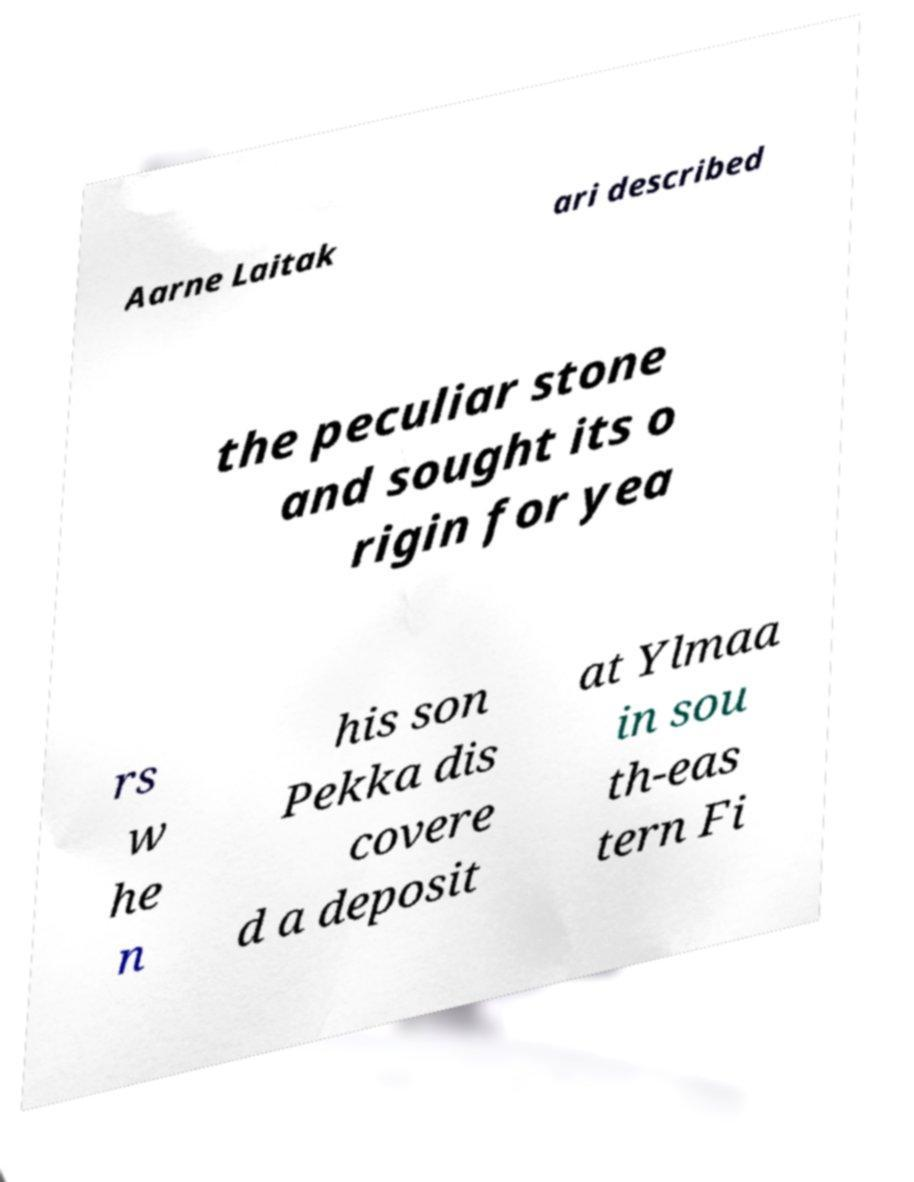Please identify and transcribe the text found in this image. Aarne Laitak ari described the peculiar stone and sought its o rigin for yea rs w he n his son Pekka dis covere d a deposit at Ylmaa in sou th-eas tern Fi 